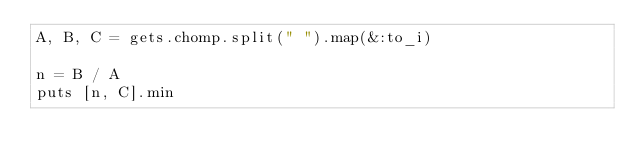Convert code to text. <code><loc_0><loc_0><loc_500><loc_500><_Ruby_>A, B, C = gets.chomp.split(" ").map(&:to_i)

n = B / A
puts [n, C].min
</code> 